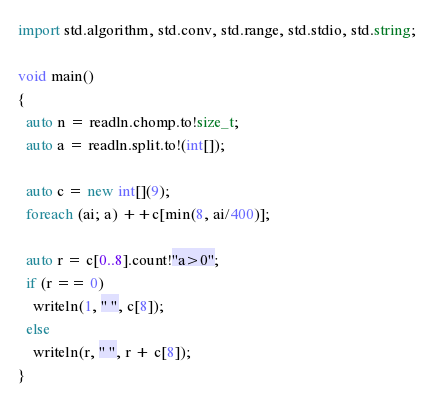Convert code to text. <code><loc_0><loc_0><loc_500><loc_500><_D_>import std.algorithm, std.conv, std.range, std.stdio, std.string;

void main()
{
  auto n = readln.chomp.to!size_t;
  auto a = readln.split.to!(int[]);

  auto c = new int[](9);
  foreach (ai; a) ++c[min(8, ai/400)];

  auto r = c[0..8].count!"a>0";
  if (r == 0)
    writeln(1, " ", c[8]);
  else
    writeln(r, " ", r + c[8]);
}
</code> 